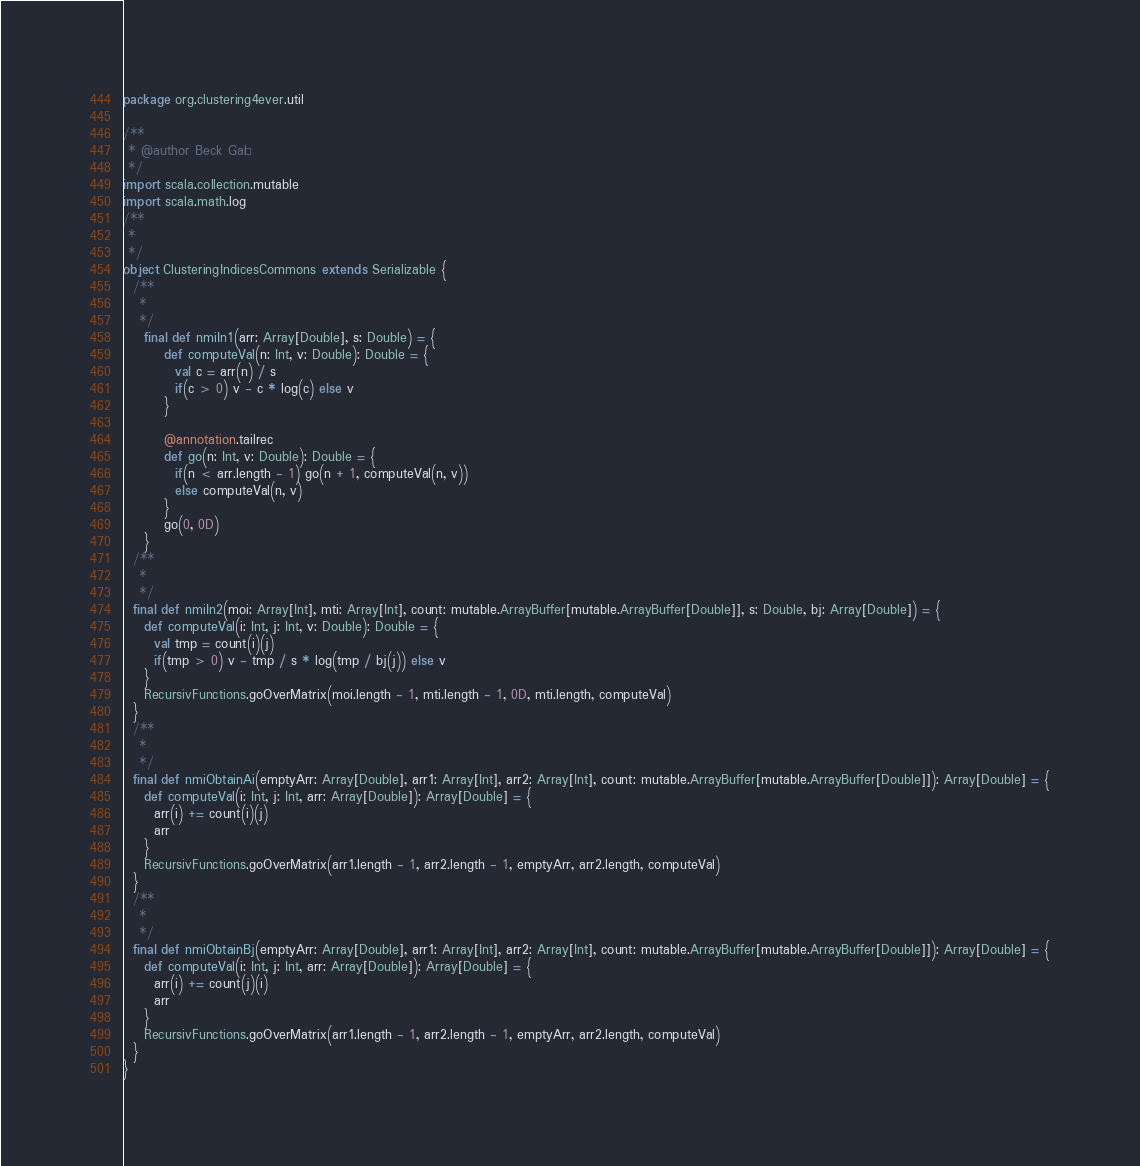Convert code to text. <code><loc_0><loc_0><loc_500><loc_500><_Scala_>package org.clustering4ever.util

/**
 * @author Beck Gaël
 */
import scala.collection.mutable
import scala.math.log
/**
 *
 */
object ClusteringIndicesCommons extends Serializable {
  /**
   *
   */
	final def nmiIn1(arr: Array[Double], s: Double) = {
		def computeVal(n: Int, v: Double): Double = {
		  val c = arr(n) / s
		  if(c > 0) v - c * log(c) else v
		}

		@annotation.tailrec
		def go(n: Int, v: Double): Double = {
		  if(n < arr.length - 1) go(n + 1, computeVal(n, v))
		  else computeVal(n, v)
		}
		go(0, 0D)
	}
  /**
   *
   */
  final def nmiIn2(moi: Array[Int], mti: Array[Int], count: mutable.ArrayBuffer[mutable.ArrayBuffer[Double]], s: Double, bj: Array[Double]) = {
    def computeVal(i: Int, j: Int, v: Double): Double = {
      val tmp = count(i)(j)
      if(tmp > 0) v - tmp / s * log(tmp / bj(j)) else v
    }
    RecursivFunctions.goOverMatrix(moi.length - 1, mti.length - 1, 0D, mti.length, computeVal)
  }
  /**
   *
   */
  final def nmiObtainAi(emptyArr: Array[Double], arr1: Array[Int], arr2: Array[Int], count: mutable.ArrayBuffer[mutable.ArrayBuffer[Double]]): Array[Double] = {
    def computeVal(i: Int, j: Int, arr: Array[Double]): Array[Double] = {
      arr(i) += count(i)(j)
      arr
    }
    RecursivFunctions.goOverMatrix(arr1.length - 1, arr2.length - 1, emptyArr, arr2.length, computeVal)
  }
  /**
   *
   */
  final def nmiObtainBj(emptyArr: Array[Double], arr1: Array[Int], arr2: Array[Int], count: mutable.ArrayBuffer[mutable.ArrayBuffer[Double]]): Array[Double] = {
    def computeVal(i: Int, j: Int, arr: Array[Double]): Array[Double] = {
      arr(i) += count(j)(i)
      arr
    }
    RecursivFunctions.goOverMatrix(arr1.length - 1, arr2.length - 1, emptyArr, arr2.length, computeVal)
  }
}</code> 